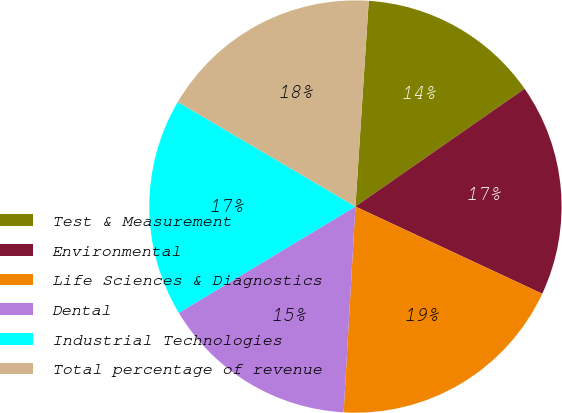<chart> <loc_0><loc_0><loc_500><loc_500><pie_chart><fcel>Test & Measurement<fcel>Environmental<fcel>Life Sciences & Diagnostics<fcel>Dental<fcel>Industrial Technologies<fcel>Total percentage of revenue<nl><fcel>14.29%<fcel>16.63%<fcel>18.96%<fcel>15.46%<fcel>17.09%<fcel>17.56%<nl></chart> 